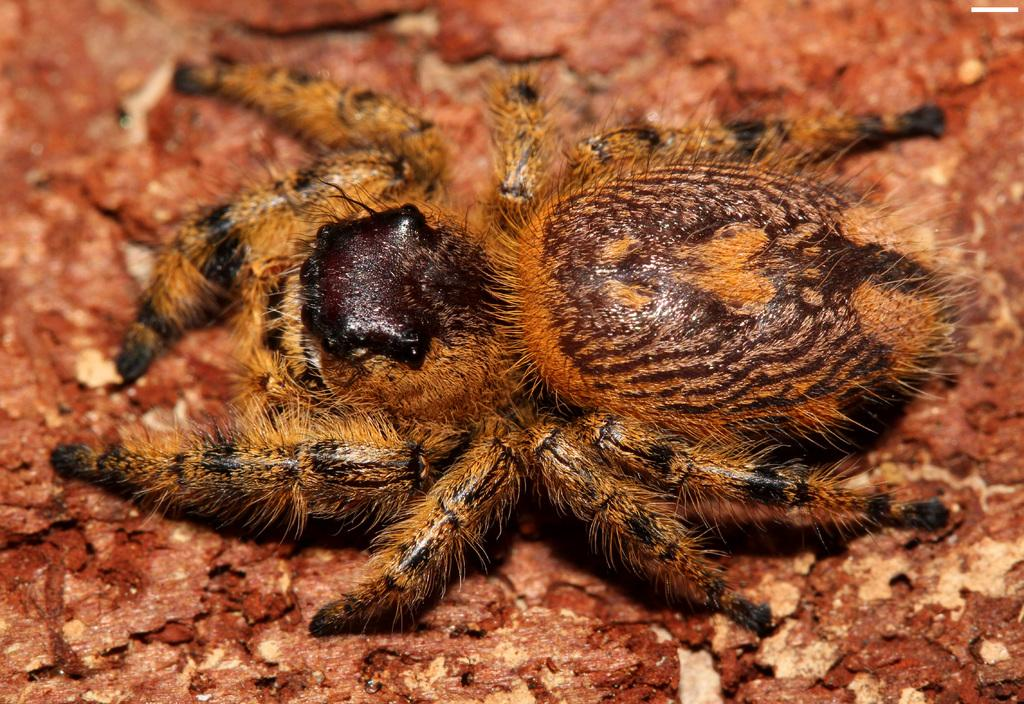What is the main subject of the image? The main subject of the image is a spider. What color is the surface on which the spider is located? The spider is on a red color surface. How many parents does the spider have in the image? Spiders do not have parents in the traditional sense, as they lay eggs and do not raise their offspring. Additionally, there is no information about the spider's family in the image. 